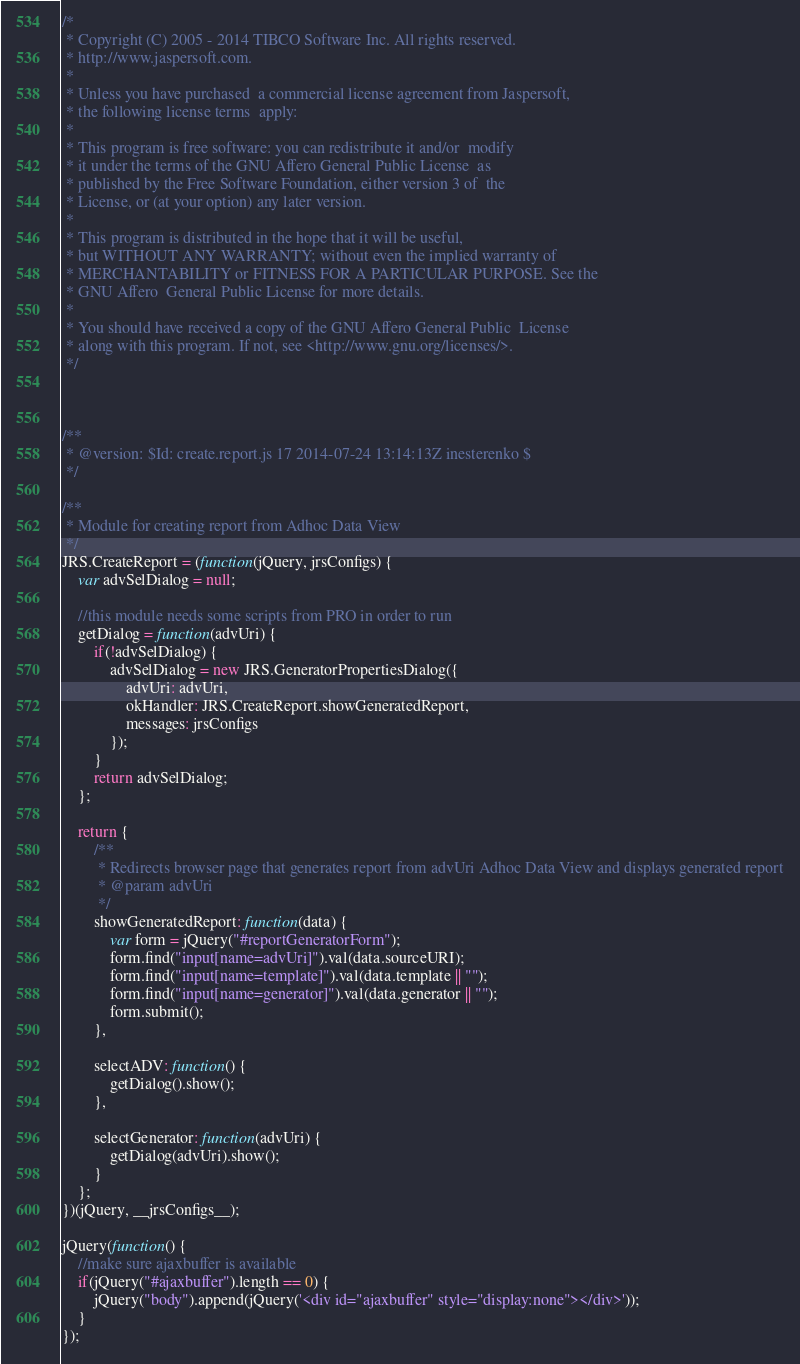<code> <loc_0><loc_0><loc_500><loc_500><_JavaScript_>/*
 * Copyright (C) 2005 - 2014 TIBCO Software Inc. All rights reserved.
 * http://www.jaspersoft.com.
 *
 * Unless you have purchased  a commercial license agreement from Jaspersoft,
 * the following license terms  apply:
 *
 * This program is free software: you can redistribute it and/or  modify
 * it under the terms of the GNU Affero General Public License  as
 * published by the Free Software Foundation, either version 3 of  the
 * License, or (at your option) any later version.
 *
 * This program is distributed in the hope that it will be useful,
 * but WITHOUT ANY WARRANTY; without even the implied warranty of
 * MERCHANTABILITY or FITNESS FOR A PARTICULAR PURPOSE. See the
 * GNU Affero  General Public License for more details.
 *
 * You should have received a copy of the GNU Affero General Public  License
 * along with this program. If not, see <http://www.gnu.org/licenses/>.
 */



/**
 * @version: $Id: create.report.js 17 2014-07-24 13:14:13Z inesterenko $
 */

/**
 * Module for creating report from Adhoc Data View
 */
JRS.CreateReport = (function(jQuery, jrsConfigs) {
    var advSelDialog = null;

    //this module needs some scripts from PRO in order to run
    getDialog = function(advUri) {
        if(!advSelDialog) {
            advSelDialog = new JRS.GeneratorPropertiesDialog({
                advUri: advUri,
                okHandler: JRS.CreateReport.showGeneratedReport,
                messages: jrsConfigs
            });
        }
        return advSelDialog;
    };

    return {
        /**
         * Redirects browser page that generates report from advUri Adhoc Data View and displays generated report
         * @param advUri
         */
        showGeneratedReport: function(data) {
            var form = jQuery("#reportGeneratorForm");
            form.find("input[name=advUri]").val(data.sourceURI);
            form.find("input[name=template]").val(data.template || "");
            form.find("input[name=generator]").val(data.generator || "");
            form.submit();
        },

        selectADV: function() {
            getDialog().show();
        },

        selectGenerator: function(advUri) {
            getDialog(advUri).show();
        }
    };
})(jQuery, __jrsConfigs__);

jQuery(function() {
    //make sure ajaxbuffer is available
    if(jQuery("#ajaxbuffer").length == 0) {
        jQuery("body").append(jQuery('<div id="ajaxbuffer" style="display:none"></div>'));
    }
});
</code> 